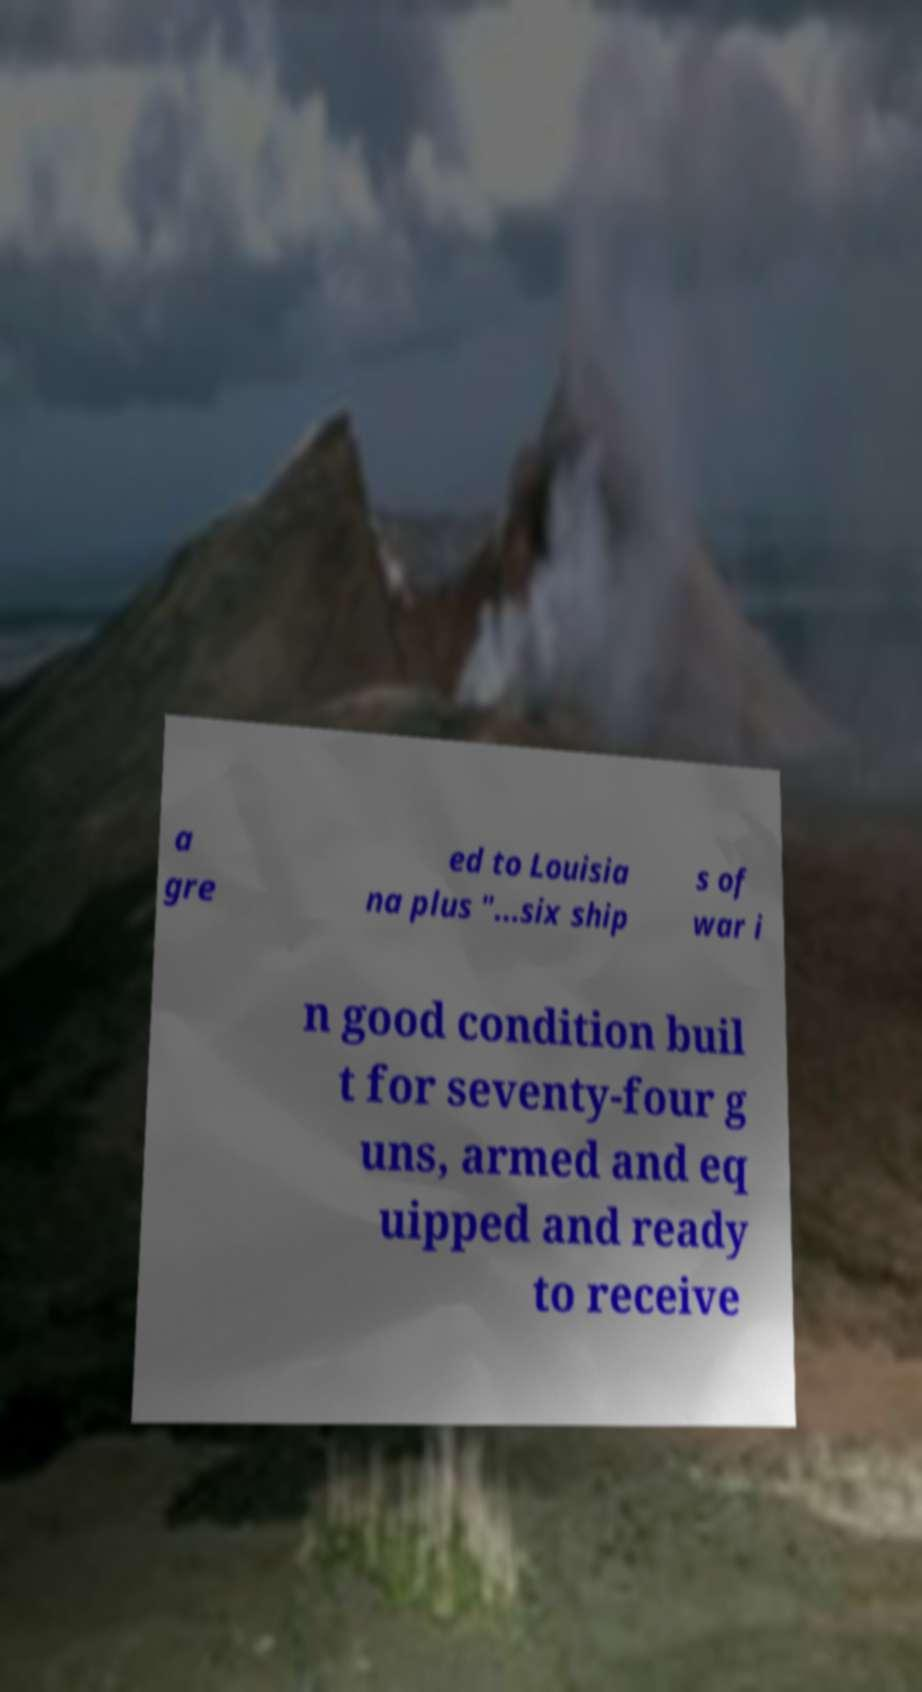I need the written content from this picture converted into text. Can you do that? a gre ed to Louisia na plus "...six ship s of war i n good condition buil t for seventy-four g uns, armed and eq uipped and ready to receive 